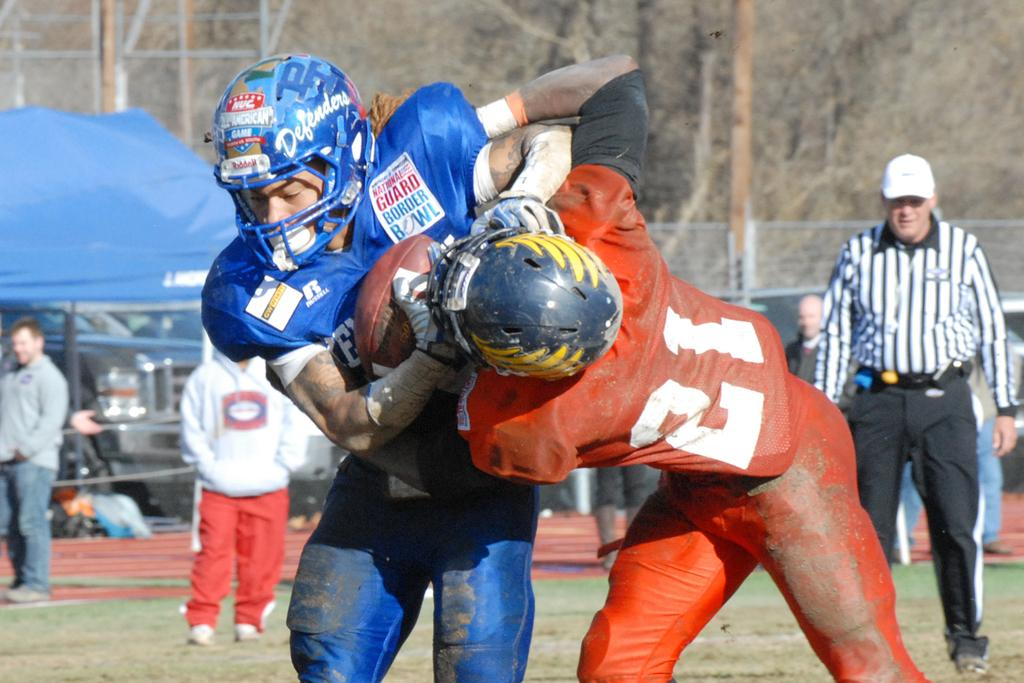How many people are in the image? There is a group of people in the image, but the exact number is not specified. What are the people in the image doing? The people are on the ground, but their specific activity is not mentioned. What can be seen in the background of the image? There is a fence and trees in the background of the image. How many trampolines are visible in the image? There is no mention of trampolines in the image; the people are simply on the ground. Can you tell me how many snails are crawling on the fence in the image? There is no mention of snails in the image; the background elements are a fence and trees. 